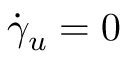<formula> <loc_0><loc_0><loc_500><loc_500>{ \dot { \gamma } } _ { u } = 0</formula> 